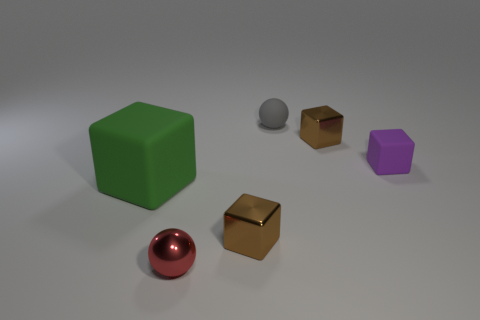Is the green object the same shape as the small purple object? yes 